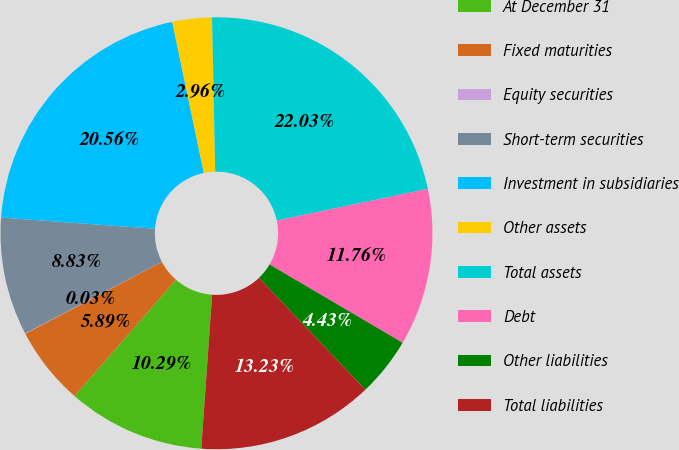<chart> <loc_0><loc_0><loc_500><loc_500><pie_chart><fcel>At December 31<fcel>Fixed maturities<fcel>Equity securities<fcel>Short-term securities<fcel>Investment in subsidiaries<fcel>Other assets<fcel>Total assets<fcel>Debt<fcel>Other liabilities<fcel>Total liabilities<nl><fcel>10.29%<fcel>5.89%<fcel>0.03%<fcel>8.83%<fcel>20.56%<fcel>2.96%<fcel>22.03%<fcel>11.76%<fcel>4.43%<fcel>13.23%<nl></chart> 